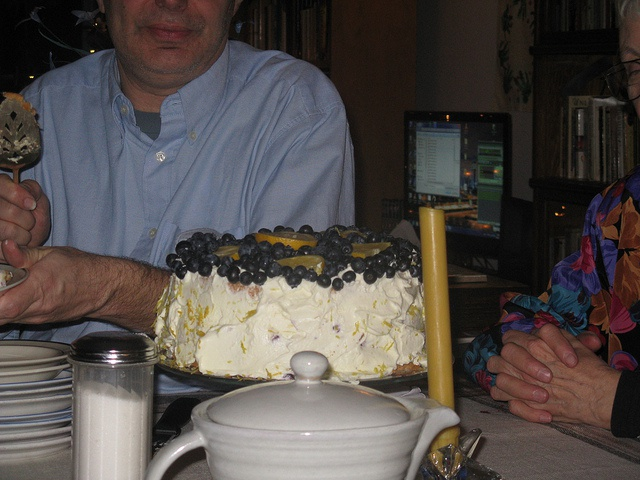Describe the objects in this image and their specific colors. I can see people in black, gray, and maroon tones, cake in black, beige, darkgray, and tan tones, people in black, maroon, and brown tones, bowl in black, darkgray, and gray tones, and bottle in black, gray, darkgray, and lightgray tones in this image. 